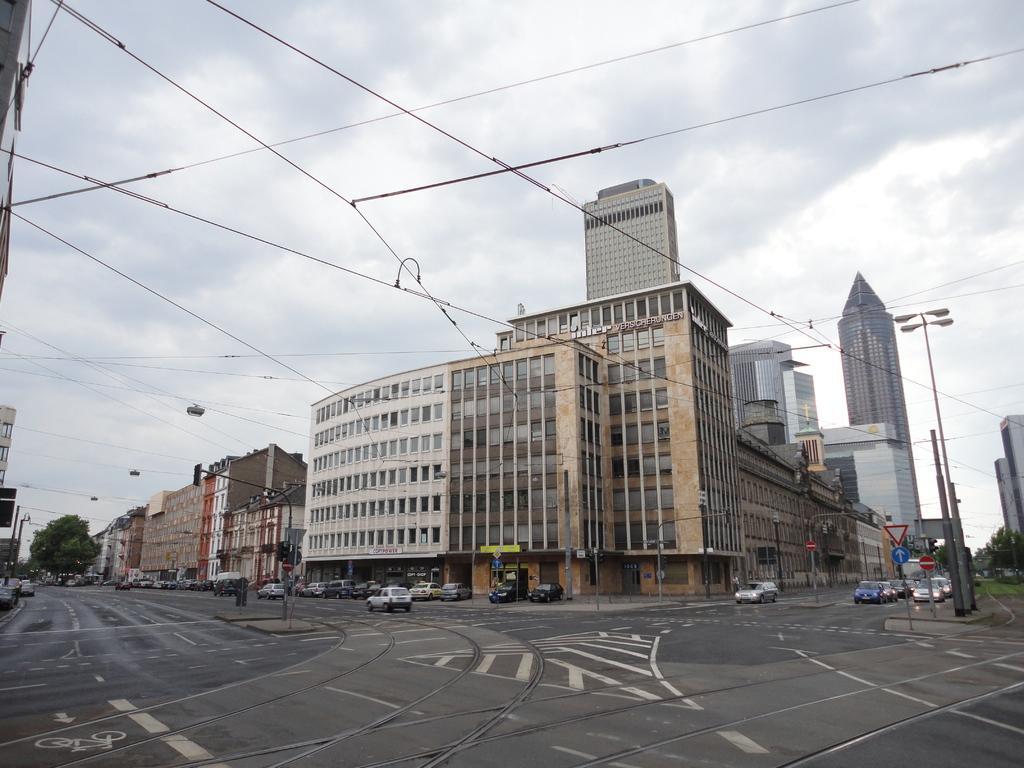Please provide a concise description of this image. In this image we can see a few buildings and vehicles on the road, there are some trees, wires, poles with lights and sign boards, in the background we can see the sky. 